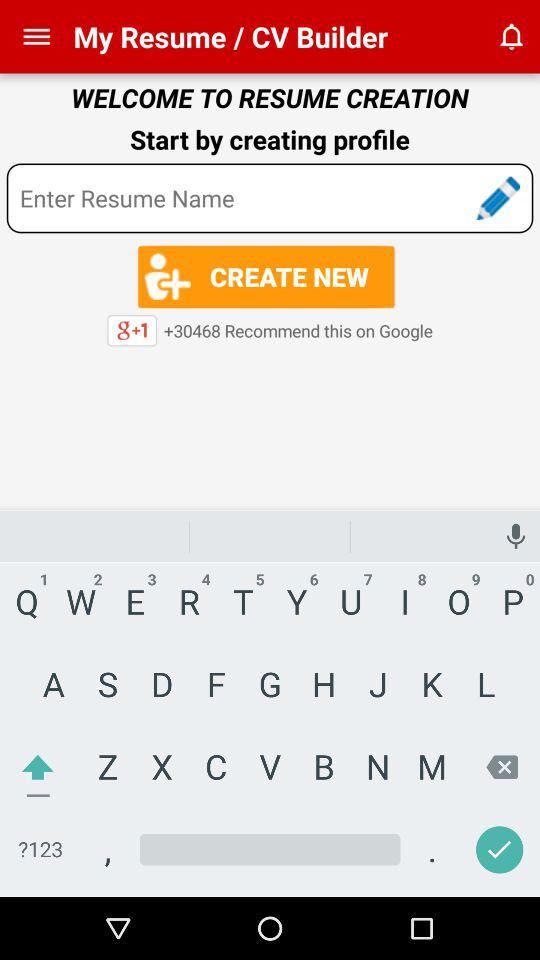What is the name of the application? The name of the application is "My Resume / CV Builder". 